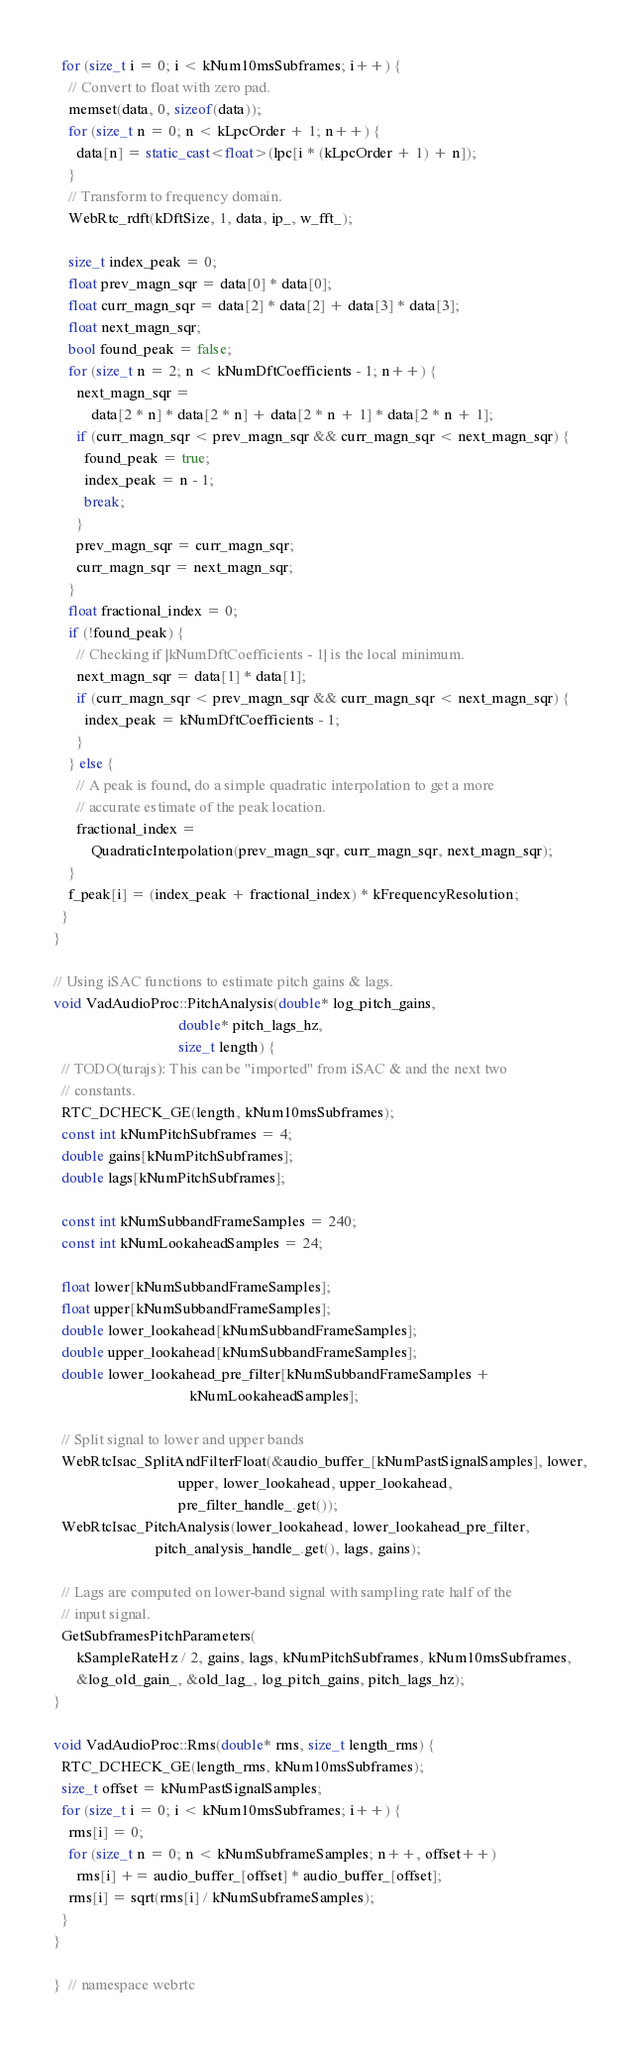<code> <loc_0><loc_0><loc_500><loc_500><_C++_>
  for (size_t i = 0; i < kNum10msSubframes; i++) {
    // Convert to float with zero pad.
    memset(data, 0, sizeof(data));
    for (size_t n = 0; n < kLpcOrder + 1; n++) {
      data[n] = static_cast<float>(lpc[i * (kLpcOrder + 1) + n]);
    }
    // Transform to frequency domain.
    WebRtc_rdft(kDftSize, 1, data, ip_, w_fft_);

    size_t index_peak = 0;
    float prev_magn_sqr = data[0] * data[0];
    float curr_magn_sqr = data[2] * data[2] + data[3] * data[3];
    float next_magn_sqr;
    bool found_peak = false;
    for (size_t n = 2; n < kNumDftCoefficients - 1; n++) {
      next_magn_sqr =
          data[2 * n] * data[2 * n] + data[2 * n + 1] * data[2 * n + 1];
      if (curr_magn_sqr < prev_magn_sqr && curr_magn_sqr < next_magn_sqr) {
        found_peak = true;
        index_peak = n - 1;
        break;
      }
      prev_magn_sqr = curr_magn_sqr;
      curr_magn_sqr = next_magn_sqr;
    }
    float fractional_index = 0;
    if (!found_peak) {
      // Checking if |kNumDftCoefficients - 1| is the local minimum.
      next_magn_sqr = data[1] * data[1];
      if (curr_magn_sqr < prev_magn_sqr && curr_magn_sqr < next_magn_sqr) {
        index_peak = kNumDftCoefficients - 1;
      }
    } else {
      // A peak is found, do a simple quadratic interpolation to get a more
      // accurate estimate of the peak location.
      fractional_index =
          QuadraticInterpolation(prev_magn_sqr, curr_magn_sqr, next_magn_sqr);
    }
    f_peak[i] = (index_peak + fractional_index) * kFrequencyResolution;
  }
}

// Using iSAC functions to estimate pitch gains & lags.
void VadAudioProc::PitchAnalysis(double* log_pitch_gains,
                                 double* pitch_lags_hz,
                                 size_t length) {
  // TODO(turajs): This can be "imported" from iSAC & and the next two
  // constants.
  RTC_DCHECK_GE(length, kNum10msSubframes);
  const int kNumPitchSubframes = 4;
  double gains[kNumPitchSubframes];
  double lags[kNumPitchSubframes];

  const int kNumSubbandFrameSamples = 240;
  const int kNumLookaheadSamples = 24;

  float lower[kNumSubbandFrameSamples];
  float upper[kNumSubbandFrameSamples];
  double lower_lookahead[kNumSubbandFrameSamples];
  double upper_lookahead[kNumSubbandFrameSamples];
  double lower_lookahead_pre_filter[kNumSubbandFrameSamples +
                                    kNumLookaheadSamples];

  // Split signal to lower and upper bands
  WebRtcIsac_SplitAndFilterFloat(&audio_buffer_[kNumPastSignalSamples], lower,
                                 upper, lower_lookahead, upper_lookahead,
                                 pre_filter_handle_.get());
  WebRtcIsac_PitchAnalysis(lower_lookahead, lower_lookahead_pre_filter,
                           pitch_analysis_handle_.get(), lags, gains);

  // Lags are computed on lower-band signal with sampling rate half of the
  // input signal.
  GetSubframesPitchParameters(
      kSampleRateHz / 2, gains, lags, kNumPitchSubframes, kNum10msSubframes,
      &log_old_gain_, &old_lag_, log_pitch_gains, pitch_lags_hz);
}

void VadAudioProc::Rms(double* rms, size_t length_rms) {
  RTC_DCHECK_GE(length_rms, kNum10msSubframes);
  size_t offset = kNumPastSignalSamples;
  for (size_t i = 0; i < kNum10msSubframes; i++) {
    rms[i] = 0;
    for (size_t n = 0; n < kNumSubframeSamples; n++, offset++)
      rms[i] += audio_buffer_[offset] * audio_buffer_[offset];
    rms[i] = sqrt(rms[i] / kNumSubframeSamples);
  }
}

}  // namespace webrtc
</code> 